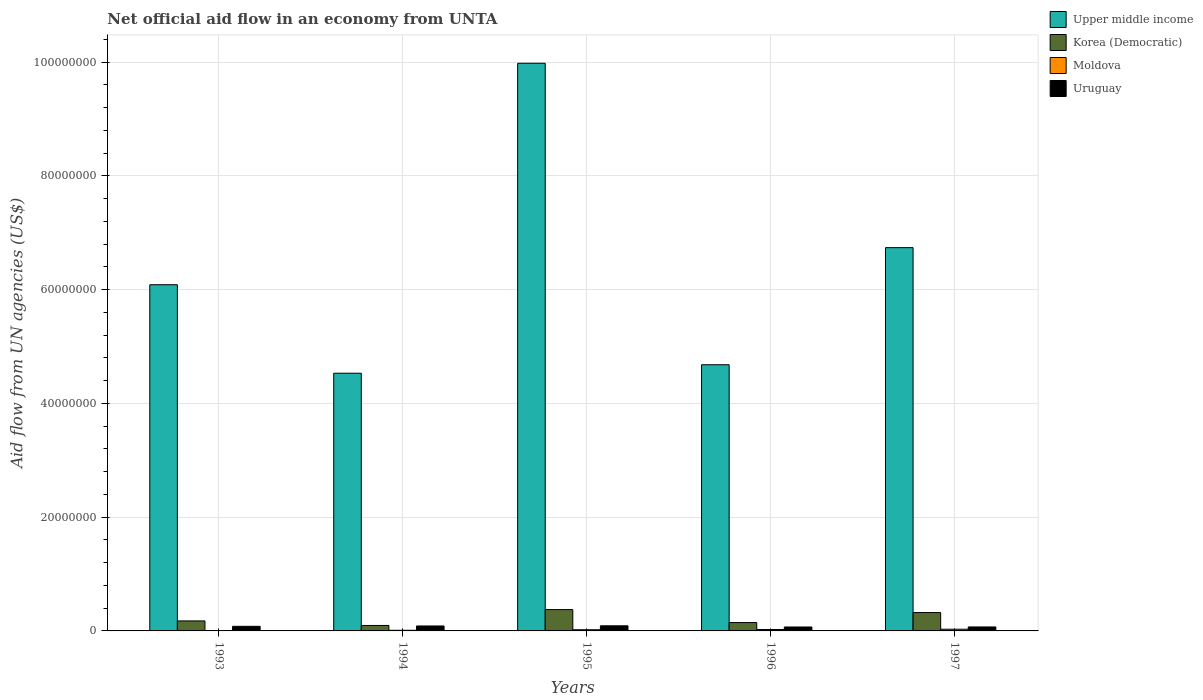Are the number of bars per tick equal to the number of legend labels?
Offer a very short reply. Yes. What is the label of the 3rd group of bars from the left?
Give a very brief answer. 1995. In how many cases, is the number of bars for a given year not equal to the number of legend labels?
Ensure brevity in your answer.  0. What is the net official aid flow in Upper middle income in 1994?
Your response must be concise. 4.53e+07. Across all years, what is the maximum net official aid flow in Upper middle income?
Your response must be concise. 9.98e+07. Across all years, what is the minimum net official aid flow in Uruguay?
Keep it short and to the point. 6.90e+05. What is the total net official aid flow in Moldova in the graph?
Keep it short and to the point. 9.30e+05. What is the difference between the net official aid flow in Moldova in 1996 and that in 1997?
Provide a succinct answer. -5.00e+04. What is the difference between the net official aid flow in Uruguay in 1993 and the net official aid flow in Upper middle income in 1994?
Give a very brief answer. -4.45e+07. What is the average net official aid flow in Upper middle income per year?
Make the answer very short. 6.40e+07. In the year 1997, what is the difference between the net official aid flow in Korea (Democratic) and net official aid flow in Moldova?
Ensure brevity in your answer.  2.93e+06. What is the ratio of the net official aid flow in Upper middle income in 1994 to that in 1996?
Ensure brevity in your answer.  0.97. Is the difference between the net official aid flow in Korea (Democratic) in 1994 and 1997 greater than the difference between the net official aid flow in Moldova in 1994 and 1997?
Keep it short and to the point. No. What is the difference between the highest and the second highest net official aid flow in Uruguay?
Keep it short and to the point. 3.00e+04. What does the 3rd bar from the left in 1996 represents?
Offer a terse response. Moldova. What does the 4th bar from the right in 1996 represents?
Ensure brevity in your answer.  Upper middle income. What is the difference between two consecutive major ticks on the Y-axis?
Give a very brief answer. 2.00e+07. Does the graph contain any zero values?
Your response must be concise. No. Does the graph contain grids?
Your answer should be compact. Yes. What is the title of the graph?
Make the answer very short. Net official aid flow in an economy from UNTA. Does "Trinidad and Tobago" appear as one of the legend labels in the graph?
Make the answer very short. No. What is the label or title of the Y-axis?
Your answer should be very brief. Aid flow from UN agencies (US$). What is the Aid flow from UN agencies (US$) of Upper middle income in 1993?
Make the answer very short. 6.09e+07. What is the Aid flow from UN agencies (US$) in Korea (Democratic) in 1993?
Your answer should be very brief. 1.76e+06. What is the Aid flow from UN agencies (US$) of Moldova in 1993?
Ensure brevity in your answer.  6.00e+04. What is the Aid flow from UN agencies (US$) of Uruguay in 1993?
Offer a terse response. 8.10e+05. What is the Aid flow from UN agencies (US$) of Upper middle income in 1994?
Keep it short and to the point. 4.53e+07. What is the Aid flow from UN agencies (US$) of Korea (Democratic) in 1994?
Offer a very short reply. 9.60e+05. What is the Aid flow from UN agencies (US$) of Moldova in 1994?
Your answer should be compact. 1.10e+05. What is the Aid flow from UN agencies (US$) of Uruguay in 1994?
Your response must be concise. 8.70e+05. What is the Aid flow from UN agencies (US$) in Upper middle income in 1995?
Give a very brief answer. 9.98e+07. What is the Aid flow from UN agencies (US$) in Korea (Democratic) in 1995?
Offer a terse response. 3.75e+06. What is the Aid flow from UN agencies (US$) in Upper middle income in 1996?
Your answer should be compact. 4.68e+07. What is the Aid flow from UN agencies (US$) of Korea (Democratic) in 1996?
Provide a short and direct response. 1.47e+06. What is the Aid flow from UN agencies (US$) of Uruguay in 1996?
Your answer should be very brief. 6.90e+05. What is the Aid flow from UN agencies (US$) in Upper middle income in 1997?
Provide a short and direct response. 6.74e+07. What is the Aid flow from UN agencies (US$) of Korea (Democratic) in 1997?
Keep it short and to the point. 3.23e+06. What is the Aid flow from UN agencies (US$) in Uruguay in 1997?
Offer a terse response. 7.00e+05. Across all years, what is the maximum Aid flow from UN agencies (US$) in Upper middle income?
Your response must be concise. 9.98e+07. Across all years, what is the maximum Aid flow from UN agencies (US$) of Korea (Democratic)?
Provide a succinct answer. 3.75e+06. Across all years, what is the maximum Aid flow from UN agencies (US$) of Moldova?
Offer a terse response. 3.00e+05. Across all years, what is the maximum Aid flow from UN agencies (US$) of Uruguay?
Ensure brevity in your answer.  9.00e+05. Across all years, what is the minimum Aid flow from UN agencies (US$) in Upper middle income?
Ensure brevity in your answer.  4.53e+07. Across all years, what is the minimum Aid flow from UN agencies (US$) of Korea (Democratic)?
Keep it short and to the point. 9.60e+05. Across all years, what is the minimum Aid flow from UN agencies (US$) in Uruguay?
Give a very brief answer. 6.90e+05. What is the total Aid flow from UN agencies (US$) in Upper middle income in the graph?
Your answer should be very brief. 3.20e+08. What is the total Aid flow from UN agencies (US$) of Korea (Democratic) in the graph?
Offer a terse response. 1.12e+07. What is the total Aid flow from UN agencies (US$) of Moldova in the graph?
Ensure brevity in your answer.  9.30e+05. What is the total Aid flow from UN agencies (US$) in Uruguay in the graph?
Provide a succinct answer. 3.97e+06. What is the difference between the Aid flow from UN agencies (US$) in Upper middle income in 1993 and that in 1994?
Provide a succinct answer. 1.56e+07. What is the difference between the Aid flow from UN agencies (US$) in Moldova in 1993 and that in 1994?
Keep it short and to the point. -5.00e+04. What is the difference between the Aid flow from UN agencies (US$) of Uruguay in 1993 and that in 1994?
Give a very brief answer. -6.00e+04. What is the difference between the Aid flow from UN agencies (US$) of Upper middle income in 1993 and that in 1995?
Your answer should be very brief. -3.89e+07. What is the difference between the Aid flow from UN agencies (US$) in Korea (Democratic) in 1993 and that in 1995?
Your response must be concise. -1.99e+06. What is the difference between the Aid flow from UN agencies (US$) of Moldova in 1993 and that in 1995?
Your answer should be compact. -1.50e+05. What is the difference between the Aid flow from UN agencies (US$) of Upper middle income in 1993 and that in 1996?
Make the answer very short. 1.41e+07. What is the difference between the Aid flow from UN agencies (US$) in Korea (Democratic) in 1993 and that in 1996?
Your answer should be compact. 2.90e+05. What is the difference between the Aid flow from UN agencies (US$) in Upper middle income in 1993 and that in 1997?
Give a very brief answer. -6.52e+06. What is the difference between the Aid flow from UN agencies (US$) of Korea (Democratic) in 1993 and that in 1997?
Provide a succinct answer. -1.47e+06. What is the difference between the Aid flow from UN agencies (US$) of Moldova in 1993 and that in 1997?
Provide a short and direct response. -2.40e+05. What is the difference between the Aid flow from UN agencies (US$) of Uruguay in 1993 and that in 1997?
Your answer should be compact. 1.10e+05. What is the difference between the Aid flow from UN agencies (US$) in Upper middle income in 1994 and that in 1995?
Your answer should be very brief. -5.45e+07. What is the difference between the Aid flow from UN agencies (US$) in Korea (Democratic) in 1994 and that in 1995?
Your response must be concise. -2.79e+06. What is the difference between the Aid flow from UN agencies (US$) in Moldova in 1994 and that in 1995?
Ensure brevity in your answer.  -1.00e+05. What is the difference between the Aid flow from UN agencies (US$) of Uruguay in 1994 and that in 1995?
Offer a very short reply. -3.00e+04. What is the difference between the Aid flow from UN agencies (US$) of Upper middle income in 1994 and that in 1996?
Provide a short and direct response. -1.49e+06. What is the difference between the Aid flow from UN agencies (US$) in Korea (Democratic) in 1994 and that in 1996?
Your response must be concise. -5.10e+05. What is the difference between the Aid flow from UN agencies (US$) of Moldova in 1994 and that in 1996?
Your response must be concise. -1.40e+05. What is the difference between the Aid flow from UN agencies (US$) of Uruguay in 1994 and that in 1996?
Ensure brevity in your answer.  1.80e+05. What is the difference between the Aid flow from UN agencies (US$) of Upper middle income in 1994 and that in 1997?
Provide a succinct answer. -2.21e+07. What is the difference between the Aid flow from UN agencies (US$) in Korea (Democratic) in 1994 and that in 1997?
Your answer should be compact. -2.27e+06. What is the difference between the Aid flow from UN agencies (US$) in Uruguay in 1994 and that in 1997?
Offer a very short reply. 1.70e+05. What is the difference between the Aid flow from UN agencies (US$) in Upper middle income in 1995 and that in 1996?
Ensure brevity in your answer.  5.30e+07. What is the difference between the Aid flow from UN agencies (US$) in Korea (Democratic) in 1995 and that in 1996?
Give a very brief answer. 2.28e+06. What is the difference between the Aid flow from UN agencies (US$) of Uruguay in 1995 and that in 1996?
Offer a terse response. 2.10e+05. What is the difference between the Aid flow from UN agencies (US$) of Upper middle income in 1995 and that in 1997?
Give a very brief answer. 3.24e+07. What is the difference between the Aid flow from UN agencies (US$) in Korea (Democratic) in 1995 and that in 1997?
Keep it short and to the point. 5.20e+05. What is the difference between the Aid flow from UN agencies (US$) in Moldova in 1995 and that in 1997?
Provide a short and direct response. -9.00e+04. What is the difference between the Aid flow from UN agencies (US$) in Uruguay in 1995 and that in 1997?
Your response must be concise. 2.00e+05. What is the difference between the Aid flow from UN agencies (US$) in Upper middle income in 1996 and that in 1997?
Ensure brevity in your answer.  -2.06e+07. What is the difference between the Aid flow from UN agencies (US$) in Korea (Democratic) in 1996 and that in 1997?
Provide a short and direct response. -1.76e+06. What is the difference between the Aid flow from UN agencies (US$) of Moldova in 1996 and that in 1997?
Ensure brevity in your answer.  -5.00e+04. What is the difference between the Aid flow from UN agencies (US$) of Upper middle income in 1993 and the Aid flow from UN agencies (US$) of Korea (Democratic) in 1994?
Your answer should be very brief. 5.99e+07. What is the difference between the Aid flow from UN agencies (US$) of Upper middle income in 1993 and the Aid flow from UN agencies (US$) of Moldova in 1994?
Make the answer very short. 6.08e+07. What is the difference between the Aid flow from UN agencies (US$) in Upper middle income in 1993 and the Aid flow from UN agencies (US$) in Uruguay in 1994?
Give a very brief answer. 6.00e+07. What is the difference between the Aid flow from UN agencies (US$) in Korea (Democratic) in 1993 and the Aid flow from UN agencies (US$) in Moldova in 1994?
Your answer should be compact. 1.65e+06. What is the difference between the Aid flow from UN agencies (US$) of Korea (Democratic) in 1993 and the Aid flow from UN agencies (US$) of Uruguay in 1994?
Offer a terse response. 8.90e+05. What is the difference between the Aid flow from UN agencies (US$) in Moldova in 1993 and the Aid flow from UN agencies (US$) in Uruguay in 1994?
Provide a succinct answer. -8.10e+05. What is the difference between the Aid flow from UN agencies (US$) in Upper middle income in 1993 and the Aid flow from UN agencies (US$) in Korea (Democratic) in 1995?
Keep it short and to the point. 5.71e+07. What is the difference between the Aid flow from UN agencies (US$) in Upper middle income in 1993 and the Aid flow from UN agencies (US$) in Moldova in 1995?
Keep it short and to the point. 6.07e+07. What is the difference between the Aid flow from UN agencies (US$) of Upper middle income in 1993 and the Aid flow from UN agencies (US$) of Uruguay in 1995?
Your response must be concise. 6.00e+07. What is the difference between the Aid flow from UN agencies (US$) of Korea (Democratic) in 1993 and the Aid flow from UN agencies (US$) of Moldova in 1995?
Keep it short and to the point. 1.55e+06. What is the difference between the Aid flow from UN agencies (US$) of Korea (Democratic) in 1993 and the Aid flow from UN agencies (US$) of Uruguay in 1995?
Give a very brief answer. 8.60e+05. What is the difference between the Aid flow from UN agencies (US$) in Moldova in 1993 and the Aid flow from UN agencies (US$) in Uruguay in 1995?
Keep it short and to the point. -8.40e+05. What is the difference between the Aid flow from UN agencies (US$) in Upper middle income in 1993 and the Aid flow from UN agencies (US$) in Korea (Democratic) in 1996?
Your answer should be very brief. 5.94e+07. What is the difference between the Aid flow from UN agencies (US$) in Upper middle income in 1993 and the Aid flow from UN agencies (US$) in Moldova in 1996?
Give a very brief answer. 6.06e+07. What is the difference between the Aid flow from UN agencies (US$) in Upper middle income in 1993 and the Aid flow from UN agencies (US$) in Uruguay in 1996?
Keep it short and to the point. 6.02e+07. What is the difference between the Aid flow from UN agencies (US$) of Korea (Democratic) in 1993 and the Aid flow from UN agencies (US$) of Moldova in 1996?
Keep it short and to the point. 1.51e+06. What is the difference between the Aid flow from UN agencies (US$) in Korea (Democratic) in 1993 and the Aid flow from UN agencies (US$) in Uruguay in 1996?
Ensure brevity in your answer.  1.07e+06. What is the difference between the Aid flow from UN agencies (US$) in Moldova in 1993 and the Aid flow from UN agencies (US$) in Uruguay in 1996?
Keep it short and to the point. -6.30e+05. What is the difference between the Aid flow from UN agencies (US$) of Upper middle income in 1993 and the Aid flow from UN agencies (US$) of Korea (Democratic) in 1997?
Your response must be concise. 5.76e+07. What is the difference between the Aid flow from UN agencies (US$) in Upper middle income in 1993 and the Aid flow from UN agencies (US$) in Moldova in 1997?
Give a very brief answer. 6.06e+07. What is the difference between the Aid flow from UN agencies (US$) in Upper middle income in 1993 and the Aid flow from UN agencies (US$) in Uruguay in 1997?
Offer a very short reply. 6.02e+07. What is the difference between the Aid flow from UN agencies (US$) in Korea (Democratic) in 1993 and the Aid flow from UN agencies (US$) in Moldova in 1997?
Keep it short and to the point. 1.46e+06. What is the difference between the Aid flow from UN agencies (US$) of Korea (Democratic) in 1993 and the Aid flow from UN agencies (US$) of Uruguay in 1997?
Your answer should be very brief. 1.06e+06. What is the difference between the Aid flow from UN agencies (US$) in Moldova in 1993 and the Aid flow from UN agencies (US$) in Uruguay in 1997?
Ensure brevity in your answer.  -6.40e+05. What is the difference between the Aid flow from UN agencies (US$) of Upper middle income in 1994 and the Aid flow from UN agencies (US$) of Korea (Democratic) in 1995?
Make the answer very short. 4.16e+07. What is the difference between the Aid flow from UN agencies (US$) in Upper middle income in 1994 and the Aid flow from UN agencies (US$) in Moldova in 1995?
Give a very brief answer. 4.51e+07. What is the difference between the Aid flow from UN agencies (US$) of Upper middle income in 1994 and the Aid flow from UN agencies (US$) of Uruguay in 1995?
Your response must be concise. 4.44e+07. What is the difference between the Aid flow from UN agencies (US$) of Korea (Democratic) in 1994 and the Aid flow from UN agencies (US$) of Moldova in 1995?
Ensure brevity in your answer.  7.50e+05. What is the difference between the Aid flow from UN agencies (US$) of Moldova in 1994 and the Aid flow from UN agencies (US$) of Uruguay in 1995?
Your answer should be compact. -7.90e+05. What is the difference between the Aid flow from UN agencies (US$) in Upper middle income in 1994 and the Aid flow from UN agencies (US$) in Korea (Democratic) in 1996?
Offer a terse response. 4.38e+07. What is the difference between the Aid flow from UN agencies (US$) in Upper middle income in 1994 and the Aid flow from UN agencies (US$) in Moldova in 1996?
Give a very brief answer. 4.51e+07. What is the difference between the Aid flow from UN agencies (US$) of Upper middle income in 1994 and the Aid flow from UN agencies (US$) of Uruguay in 1996?
Keep it short and to the point. 4.46e+07. What is the difference between the Aid flow from UN agencies (US$) of Korea (Democratic) in 1994 and the Aid flow from UN agencies (US$) of Moldova in 1996?
Keep it short and to the point. 7.10e+05. What is the difference between the Aid flow from UN agencies (US$) of Korea (Democratic) in 1994 and the Aid flow from UN agencies (US$) of Uruguay in 1996?
Offer a very short reply. 2.70e+05. What is the difference between the Aid flow from UN agencies (US$) in Moldova in 1994 and the Aid flow from UN agencies (US$) in Uruguay in 1996?
Offer a terse response. -5.80e+05. What is the difference between the Aid flow from UN agencies (US$) of Upper middle income in 1994 and the Aid flow from UN agencies (US$) of Korea (Democratic) in 1997?
Provide a succinct answer. 4.21e+07. What is the difference between the Aid flow from UN agencies (US$) of Upper middle income in 1994 and the Aid flow from UN agencies (US$) of Moldova in 1997?
Offer a very short reply. 4.50e+07. What is the difference between the Aid flow from UN agencies (US$) of Upper middle income in 1994 and the Aid flow from UN agencies (US$) of Uruguay in 1997?
Provide a short and direct response. 4.46e+07. What is the difference between the Aid flow from UN agencies (US$) of Moldova in 1994 and the Aid flow from UN agencies (US$) of Uruguay in 1997?
Provide a succinct answer. -5.90e+05. What is the difference between the Aid flow from UN agencies (US$) of Upper middle income in 1995 and the Aid flow from UN agencies (US$) of Korea (Democratic) in 1996?
Your answer should be compact. 9.83e+07. What is the difference between the Aid flow from UN agencies (US$) in Upper middle income in 1995 and the Aid flow from UN agencies (US$) in Moldova in 1996?
Your answer should be very brief. 9.96e+07. What is the difference between the Aid flow from UN agencies (US$) in Upper middle income in 1995 and the Aid flow from UN agencies (US$) in Uruguay in 1996?
Give a very brief answer. 9.91e+07. What is the difference between the Aid flow from UN agencies (US$) of Korea (Democratic) in 1995 and the Aid flow from UN agencies (US$) of Moldova in 1996?
Provide a succinct answer. 3.50e+06. What is the difference between the Aid flow from UN agencies (US$) in Korea (Democratic) in 1995 and the Aid flow from UN agencies (US$) in Uruguay in 1996?
Your answer should be compact. 3.06e+06. What is the difference between the Aid flow from UN agencies (US$) in Moldova in 1995 and the Aid flow from UN agencies (US$) in Uruguay in 1996?
Give a very brief answer. -4.80e+05. What is the difference between the Aid flow from UN agencies (US$) in Upper middle income in 1995 and the Aid flow from UN agencies (US$) in Korea (Democratic) in 1997?
Your response must be concise. 9.66e+07. What is the difference between the Aid flow from UN agencies (US$) of Upper middle income in 1995 and the Aid flow from UN agencies (US$) of Moldova in 1997?
Offer a very short reply. 9.95e+07. What is the difference between the Aid flow from UN agencies (US$) in Upper middle income in 1995 and the Aid flow from UN agencies (US$) in Uruguay in 1997?
Your answer should be very brief. 9.91e+07. What is the difference between the Aid flow from UN agencies (US$) of Korea (Democratic) in 1995 and the Aid flow from UN agencies (US$) of Moldova in 1997?
Offer a very short reply. 3.45e+06. What is the difference between the Aid flow from UN agencies (US$) of Korea (Democratic) in 1995 and the Aid flow from UN agencies (US$) of Uruguay in 1997?
Your answer should be compact. 3.05e+06. What is the difference between the Aid flow from UN agencies (US$) in Moldova in 1995 and the Aid flow from UN agencies (US$) in Uruguay in 1997?
Make the answer very short. -4.90e+05. What is the difference between the Aid flow from UN agencies (US$) of Upper middle income in 1996 and the Aid flow from UN agencies (US$) of Korea (Democratic) in 1997?
Provide a succinct answer. 4.36e+07. What is the difference between the Aid flow from UN agencies (US$) of Upper middle income in 1996 and the Aid flow from UN agencies (US$) of Moldova in 1997?
Ensure brevity in your answer.  4.65e+07. What is the difference between the Aid flow from UN agencies (US$) of Upper middle income in 1996 and the Aid flow from UN agencies (US$) of Uruguay in 1997?
Offer a very short reply. 4.61e+07. What is the difference between the Aid flow from UN agencies (US$) of Korea (Democratic) in 1996 and the Aid flow from UN agencies (US$) of Moldova in 1997?
Offer a terse response. 1.17e+06. What is the difference between the Aid flow from UN agencies (US$) of Korea (Democratic) in 1996 and the Aid flow from UN agencies (US$) of Uruguay in 1997?
Provide a succinct answer. 7.70e+05. What is the difference between the Aid flow from UN agencies (US$) of Moldova in 1996 and the Aid flow from UN agencies (US$) of Uruguay in 1997?
Keep it short and to the point. -4.50e+05. What is the average Aid flow from UN agencies (US$) in Upper middle income per year?
Your answer should be compact. 6.40e+07. What is the average Aid flow from UN agencies (US$) of Korea (Democratic) per year?
Make the answer very short. 2.23e+06. What is the average Aid flow from UN agencies (US$) of Moldova per year?
Your response must be concise. 1.86e+05. What is the average Aid flow from UN agencies (US$) in Uruguay per year?
Offer a very short reply. 7.94e+05. In the year 1993, what is the difference between the Aid flow from UN agencies (US$) in Upper middle income and Aid flow from UN agencies (US$) in Korea (Democratic)?
Your response must be concise. 5.91e+07. In the year 1993, what is the difference between the Aid flow from UN agencies (US$) in Upper middle income and Aid flow from UN agencies (US$) in Moldova?
Offer a very short reply. 6.08e+07. In the year 1993, what is the difference between the Aid flow from UN agencies (US$) in Upper middle income and Aid flow from UN agencies (US$) in Uruguay?
Provide a short and direct response. 6.01e+07. In the year 1993, what is the difference between the Aid flow from UN agencies (US$) in Korea (Democratic) and Aid flow from UN agencies (US$) in Moldova?
Give a very brief answer. 1.70e+06. In the year 1993, what is the difference between the Aid flow from UN agencies (US$) of Korea (Democratic) and Aid flow from UN agencies (US$) of Uruguay?
Keep it short and to the point. 9.50e+05. In the year 1993, what is the difference between the Aid flow from UN agencies (US$) of Moldova and Aid flow from UN agencies (US$) of Uruguay?
Your answer should be very brief. -7.50e+05. In the year 1994, what is the difference between the Aid flow from UN agencies (US$) in Upper middle income and Aid flow from UN agencies (US$) in Korea (Democratic)?
Offer a very short reply. 4.44e+07. In the year 1994, what is the difference between the Aid flow from UN agencies (US$) in Upper middle income and Aid flow from UN agencies (US$) in Moldova?
Your answer should be compact. 4.52e+07. In the year 1994, what is the difference between the Aid flow from UN agencies (US$) in Upper middle income and Aid flow from UN agencies (US$) in Uruguay?
Give a very brief answer. 4.44e+07. In the year 1994, what is the difference between the Aid flow from UN agencies (US$) of Korea (Democratic) and Aid flow from UN agencies (US$) of Moldova?
Your answer should be very brief. 8.50e+05. In the year 1994, what is the difference between the Aid flow from UN agencies (US$) of Korea (Democratic) and Aid flow from UN agencies (US$) of Uruguay?
Your answer should be very brief. 9.00e+04. In the year 1994, what is the difference between the Aid flow from UN agencies (US$) of Moldova and Aid flow from UN agencies (US$) of Uruguay?
Provide a short and direct response. -7.60e+05. In the year 1995, what is the difference between the Aid flow from UN agencies (US$) in Upper middle income and Aid flow from UN agencies (US$) in Korea (Democratic)?
Your response must be concise. 9.61e+07. In the year 1995, what is the difference between the Aid flow from UN agencies (US$) in Upper middle income and Aid flow from UN agencies (US$) in Moldova?
Make the answer very short. 9.96e+07. In the year 1995, what is the difference between the Aid flow from UN agencies (US$) of Upper middle income and Aid flow from UN agencies (US$) of Uruguay?
Ensure brevity in your answer.  9.89e+07. In the year 1995, what is the difference between the Aid flow from UN agencies (US$) of Korea (Democratic) and Aid flow from UN agencies (US$) of Moldova?
Your answer should be very brief. 3.54e+06. In the year 1995, what is the difference between the Aid flow from UN agencies (US$) of Korea (Democratic) and Aid flow from UN agencies (US$) of Uruguay?
Give a very brief answer. 2.85e+06. In the year 1995, what is the difference between the Aid flow from UN agencies (US$) of Moldova and Aid flow from UN agencies (US$) of Uruguay?
Keep it short and to the point. -6.90e+05. In the year 1996, what is the difference between the Aid flow from UN agencies (US$) of Upper middle income and Aid flow from UN agencies (US$) of Korea (Democratic)?
Keep it short and to the point. 4.53e+07. In the year 1996, what is the difference between the Aid flow from UN agencies (US$) of Upper middle income and Aid flow from UN agencies (US$) of Moldova?
Your answer should be compact. 4.66e+07. In the year 1996, what is the difference between the Aid flow from UN agencies (US$) of Upper middle income and Aid flow from UN agencies (US$) of Uruguay?
Your answer should be compact. 4.61e+07. In the year 1996, what is the difference between the Aid flow from UN agencies (US$) in Korea (Democratic) and Aid flow from UN agencies (US$) in Moldova?
Give a very brief answer. 1.22e+06. In the year 1996, what is the difference between the Aid flow from UN agencies (US$) in Korea (Democratic) and Aid flow from UN agencies (US$) in Uruguay?
Offer a very short reply. 7.80e+05. In the year 1996, what is the difference between the Aid flow from UN agencies (US$) of Moldova and Aid flow from UN agencies (US$) of Uruguay?
Make the answer very short. -4.40e+05. In the year 1997, what is the difference between the Aid flow from UN agencies (US$) of Upper middle income and Aid flow from UN agencies (US$) of Korea (Democratic)?
Provide a succinct answer. 6.42e+07. In the year 1997, what is the difference between the Aid flow from UN agencies (US$) in Upper middle income and Aid flow from UN agencies (US$) in Moldova?
Your answer should be compact. 6.71e+07. In the year 1997, what is the difference between the Aid flow from UN agencies (US$) in Upper middle income and Aid flow from UN agencies (US$) in Uruguay?
Make the answer very short. 6.67e+07. In the year 1997, what is the difference between the Aid flow from UN agencies (US$) of Korea (Democratic) and Aid flow from UN agencies (US$) of Moldova?
Provide a short and direct response. 2.93e+06. In the year 1997, what is the difference between the Aid flow from UN agencies (US$) of Korea (Democratic) and Aid flow from UN agencies (US$) of Uruguay?
Ensure brevity in your answer.  2.53e+06. In the year 1997, what is the difference between the Aid flow from UN agencies (US$) in Moldova and Aid flow from UN agencies (US$) in Uruguay?
Offer a terse response. -4.00e+05. What is the ratio of the Aid flow from UN agencies (US$) in Upper middle income in 1993 to that in 1994?
Provide a succinct answer. 1.34. What is the ratio of the Aid flow from UN agencies (US$) in Korea (Democratic) in 1993 to that in 1994?
Make the answer very short. 1.83. What is the ratio of the Aid flow from UN agencies (US$) of Moldova in 1993 to that in 1994?
Provide a succinct answer. 0.55. What is the ratio of the Aid flow from UN agencies (US$) of Upper middle income in 1993 to that in 1995?
Provide a succinct answer. 0.61. What is the ratio of the Aid flow from UN agencies (US$) in Korea (Democratic) in 1993 to that in 1995?
Your answer should be compact. 0.47. What is the ratio of the Aid flow from UN agencies (US$) in Moldova in 1993 to that in 1995?
Provide a succinct answer. 0.29. What is the ratio of the Aid flow from UN agencies (US$) of Uruguay in 1993 to that in 1995?
Your answer should be very brief. 0.9. What is the ratio of the Aid flow from UN agencies (US$) in Upper middle income in 1993 to that in 1996?
Your response must be concise. 1.3. What is the ratio of the Aid flow from UN agencies (US$) in Korea (Democratic) in 1993 to that in 1996?
Keep it short and to the point. 1.2. What is the ratio of the Aid flow from UN agencies (US$) in Moldova in 1993 to that in 1996?
Keep it short and to the point. 0.24. What is the ratio of the Aid flow from UN agencies (US$) in Uruguay in 1993 to that in 1996?
Your response must be concise. 1.17. What is the ratio of the Aid flow from UN agencies (US$) in Upper middle income in 1993 to that in 1997?
Provide a short and direct response. 0.9. What is the ratio of the Aid flow from UN agencies (US$) in Korea (Democratic) in 1993 to that in 1997?
Give a very brief answer. 0.54. What is the ratio of the Aid flow from UN agencies (US$) of Uruguay in 1993 to that in 1997?
Provide a short and direct response. 1.16. What is the ratio of the Aid flow from UN agencies (US$) in Upper middle income in 1994 to that in 1995?
Offer a very short reply. 0.45. What is the ratio of the Aid flow from UN agencies (US$) in Korea (Democratic) in 1994 to that in 1995?
Give a very brief answer. 0.26. What is the ratio of the Aid flow from UN agencies (US$) of Moldova in 1994 to that in 1995?
Keep it short and to the point. 0.52. What is the ratio of the Aid flow from UN agencies (US$) of Uruguay in 1994 to that in 1995?
Ensure brevity in your answer.  0.97. What is the ratio of the Aid flow from UN agencies (US$) of Upper middle income in 1994 to that in 1996?
Offer a terse response. 0.97. What is the ratio of the Aid flow from UN agencies (US$) of Korea (Democratic) in 1994 to that in 1996?
Ensure brevity in your answer.  0.65. What is the ratio of the Aid flow from UN agencies (US$) in Moldova in 1994 to that in 1996?
Your answer should be very brief. 0.44. What is the ratio of the Aid flow from UN agencies (US$) in Uruguay in 1994 to that in 1996?
Your answer should be very brief. 1.26. What is the ratio of the Aid flow from UN agencies (US$) of Upper middle income in 1994 to that in 1997?
Offer a very short reply. 0.67. What is the ratio of the Aid flow from UN agencies (US$) of Korea (Democratic) in 1994 to that in 1997?
Offer a very short reply. 0.3. What is the ratio of the Aid flow from UN agencies (US$) in Moldova in 1994 to that in 1997?
Offer a terse response. 0.37. What is the ratio of the Aid flow from UN agencies (US$) in Uruguay in 1994 to that in 1997?
Offer a terse response. 1.24. What is the ratio of the Aid flow from UN agencies (US$) of Upper middle income in 1995 to that in 1996?
Provide a short and direct response. 2.13. What is the ratio of the Aid flow from UN agencies (US$) in Korea (Democratic) in 1995 to that in 1996?
Your answer should be compact. 2.55. What is the ratio of the Aid flow from UN agencies (US$) in Moldova in 1995 to that in 1996?
Your answer should be compact. 0.84. What is the ratio of the Aid flow from UN agencies (US$) of Uruguay in 1995 to that in 1996?
Give a very brief answer. 1.3. What is the ratio of the Aid flow from UN agencies (US$) in Upper middle income in 1995 to that in 1997?
Provide a succinct answer. 1.48. What is the ratio of the Aid flow from UN agencies (US$) of Korea (Democratic) in 1995 to that in 1997?
Offer a very short reply. 1.16. What is the ratio of the Aid flow from UN agencies (US$) in Uruguay in 1995 to that in 1997?
Keep it short and to the point. 1.29. What is the ratio of the Aid flow from UN agencies (US$) in Upper middle income in 1996 to that in 1997?
Make the answer very short. 0.69. What is the ratio of the Aid flow from UN agencies (US$) of Korea (Democratic) in 1996 to that in 1997?
Provide a succinct answer. 0.46. What is the ratio of the Aid flow from UN agencies (US$) of Uruguay in 1996 to that in 1997?
Offer a terse response. 0.99. What is the difference between the highest and the second highest Aid flow from UN agencies (US$) in Upper middle income?
Keep it short and to the point. 3.24e+07. What is the difference between the highest and the second highest Aid flow from UN agencies (US$) of Korea (Democratic)?
Provide a short and direct response. 5.20e+05. What is the difference between the highest and the second highest Aid flow from UN agencies (US$) in Uruguay?
Provide a succinct answer. 3.00e+04. What is the difference between the highest and the lowest Aid flow from UN agencies (US$) in Upper middle income?
Offer a terse response. 5.45e+07. What is the difference between the highest and the lowest Aid flow from UN agencies (US$) in Korea (Democratic)?
Give a very brief answer. 2.79e+06. What is the difference between the highest and the lowest Aid flow from UN agencies (US$) in Moldova?
Offer a terse response. 2.40e+05. What is the difference between the highest and the lowest Aid flow from UN agencies (US$) of Uruguay?
Keep it short and to the point. 2.10e+05. 